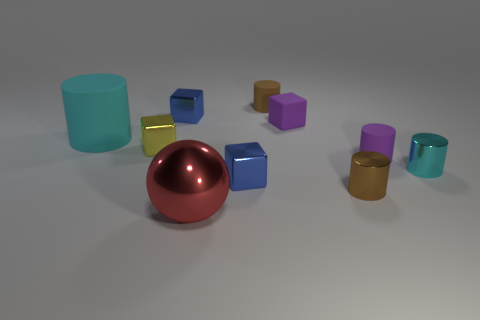Subtract all tiny shiny blocks. How many blocks are left? 1 Subtract all spheres. How many objects are left? 9 Add 3 small brown objects. How many small brown objects are left? 5 Add 5 tiny cyan rubber cubes. How many tiny cyan rubber cubes exist? 5 Subtract all blue cubes. How many cubes are left? 2 Subtract 1 red spheres. How many objects are left? 9 Subtract 2 cylinders. How many cylinders are left? 3 Subtract all gray blocks. Subtract all yellow balls. How many blocks are left? 4 Subtract all yellow cylinders. How many purple cubes are left? 1 Subtract all small yellow metallic objects. Subtract all metallic cylinders. How many objects are left? 7 